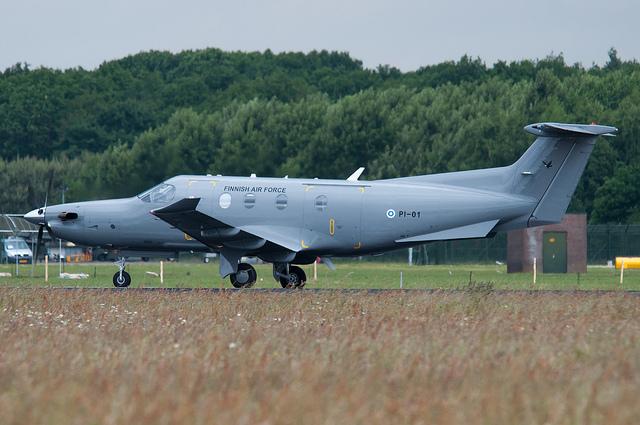Is this a military plane?
Answer briefly. Yes. Is the plane taking off?
Short answer required. No. What country is this?
Answer briefly. France. 